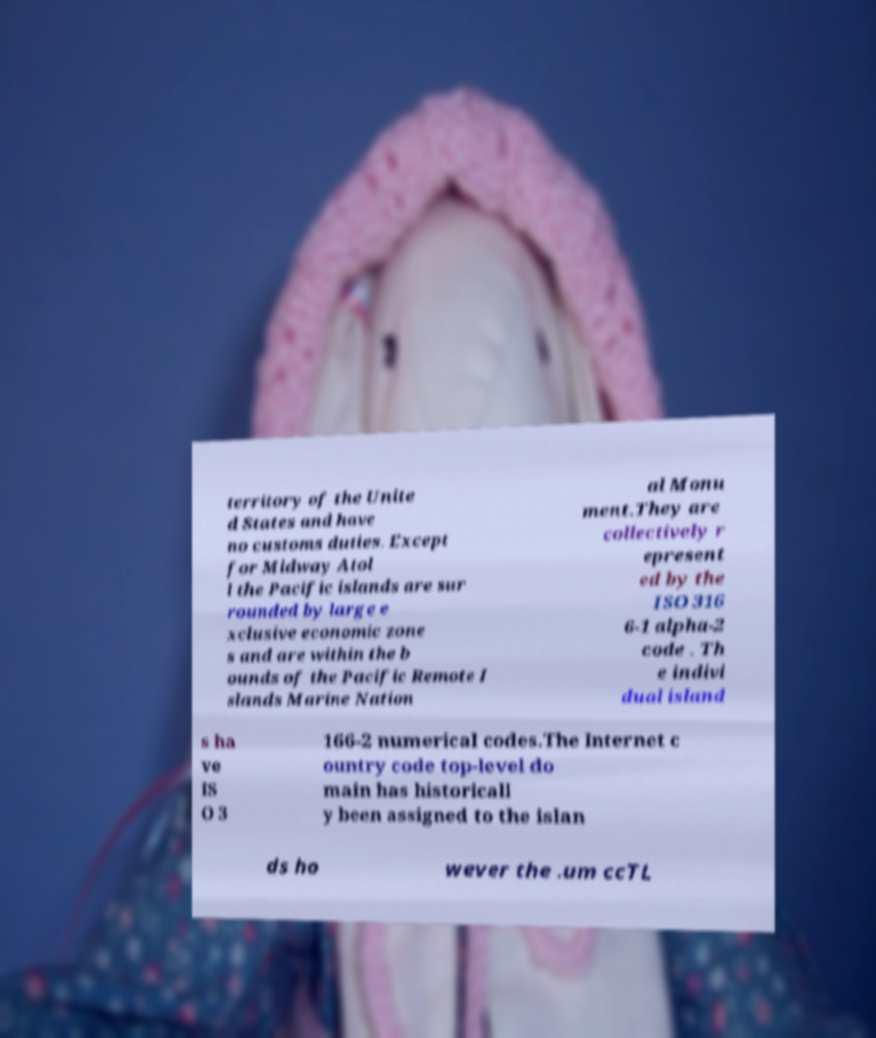Please identify and transcribe the text found in this image. territory of the Unite d States and have no customs duties. Except for Midway Atol l the Pacific islands are sur rounded by large e xclusive economic zone s and are within the b ounds of the Pacific Remote I slands Marine Nation al Monu ment.They are collectively r epresent ed by the ISO 316 6-1 alpha-2 code . Th e indivi dual island s ha ve IS O 3 166-2 numerical codes.The Internet c ountry code top-level do main has historicall y been assigned to the islan ds ho wever the .um ccTL 